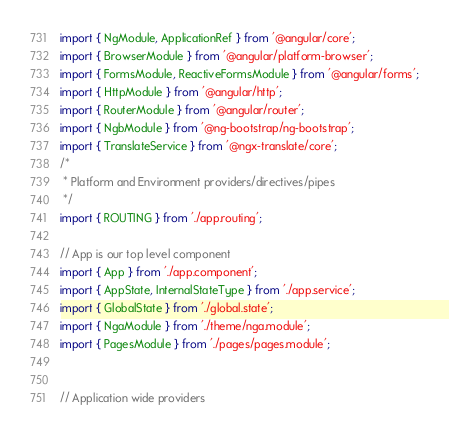<code> <loc_0><loc_0><loc_500><loc_500><_TypeScript_>import { NgModule, ApplicationRef } from '@angular/core';
import { BrowserModule } from '@angular/platform-browser';
import { FormsModule, ReactiveFormsModule } from '@angular/forms';
import { HttpModule } from '@angular/http';
import { RouterModule } from '@angular/router';
import { NgbModule } from '@ng-bootstrap/ng-bootstrap';
import { TranslateService } from '@ngx-translate/core';
/*
 * Platform and Environment providers/directives/pipes
 */
import { ROUTING } from './app.routing';

// App is our top level component
import { App } from './app.component';
import { AppState, InternalStateType } from './app.service';
import { GlobalState } from './global.state';
import { NgaModule } from './theme/nga.module';
import { PagesModule } from './pages/pages.module';


// Application wide providers</code> 